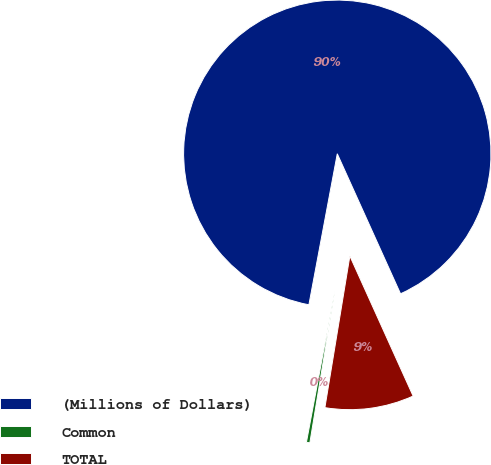Convert chart to OTSL. <chart><loc_0><loc_0><loc_500><loc_500><pie_chart><fcel>(Millions of Dollars)<fcel>Common<fcel>TOTAL<nl><fcel>90.29%<fcel>0.36%<fcel>9.35%<nl></chart> 